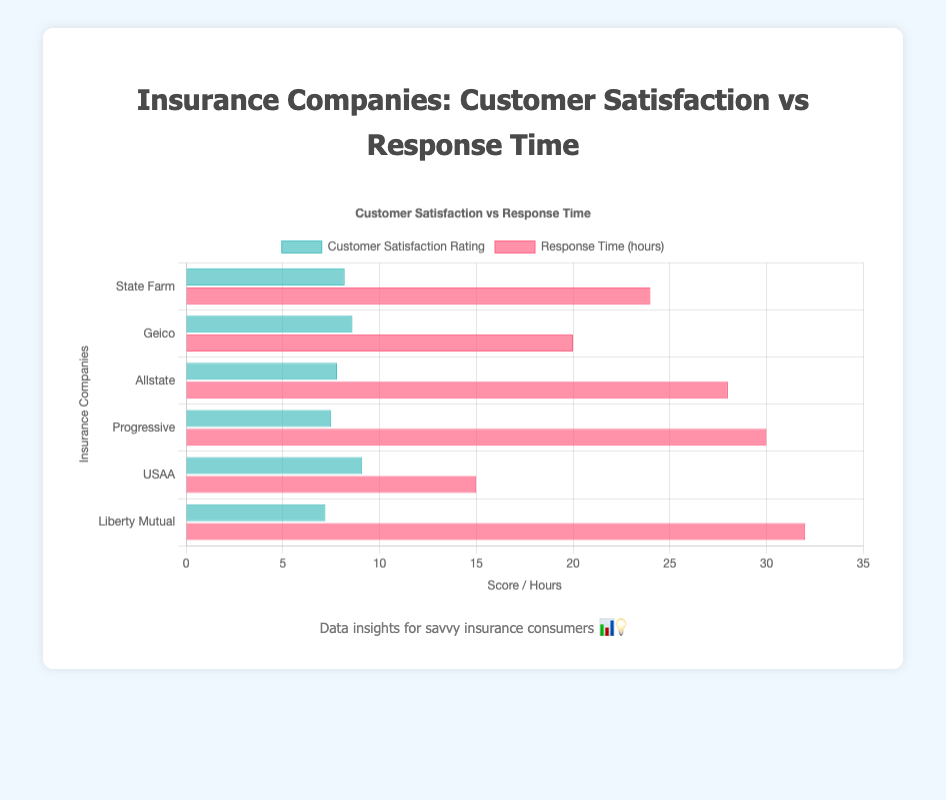Which insurance company has the highest customer satisfaction rating? The customer satisfaction rating can be identified by the heights of the blue bars. USAA has the highest blue bar, corresponding to a rating of 9.1.
Answer: USAA Which insurance company has the longest response time? The response time is represented by the lengths of the red bars. Liberty Mutual has the longest red bar, indicating a response time of 32 hours.
Answer: Liberty Mutual What is the difference in customer satisfaction rating between State Farm and Geico? The customer satisfaction rating for State Farm is 8.2 and for Geico is 8.6. Subtract the rating of State Farm from Geico to find the difference: 8.6 - 8.2 = 0.4.
Answer: 0.4 Compare the response times of Allstate and Progressive. Which company is faster? The response time for Allstate is 28 hours and for Progressive is 30 hours. Since 28 hours is less than 30 hours, Allstate has a faster response time.
Answer: Allstate What is the average customer satisfaction rating across all insurance companies shown? Sum the customer satisfaction ratings: 8.2 (State Farm) + 8.6 (Geico) + 7.8 (Allstate) + 7.5 (Progressive) + 9.1 (USAA) + 7.2 (Liberty Mutual) = 48.4. There are 6 companies, so divide the sum by 6: 48.4 / 6 ≈ 8.1.
Answer: 8.1 Which insurance company has the lowest customer satisfaction rating? The customer satisfaction rating can be determined by the blue bars' heights. Liberty Mutual has the lowest blue bar with a rating of 7.2.
Answer: Liberty Mutual What is the total response time for all companies combined? Sum the response times: 24 (State Farm) + 20 (Geico) + 28 (Allstate) + 30 (Progressive) + 15 (USAA) + 32 (Liberty Mutual) = 149 hours.
Answer: 149 How does the response time of USAA compare to the other companies? USAA has the shortest response time represented by the shortest red bar (15 hours). No other company has a response time equal to or lower than 15 hours.
Answer: USAA has the shortest response time If we rank the insurance companies according to their customer satisfaction rating from highest to lowest, which company comes third? The customer satisfaction ratings in descending order are: 9.1 (USAA), 8.6 (Geico), 8.2 (State Farm). The third is State Farm.
Answer: State Farm 